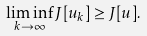<formula> <loc_0><loc_0><loc_500><loc_500>\liminf _ { k \rightarrow \infty } J [ u _ { k } ] \geq J [ u ] .</formula> 